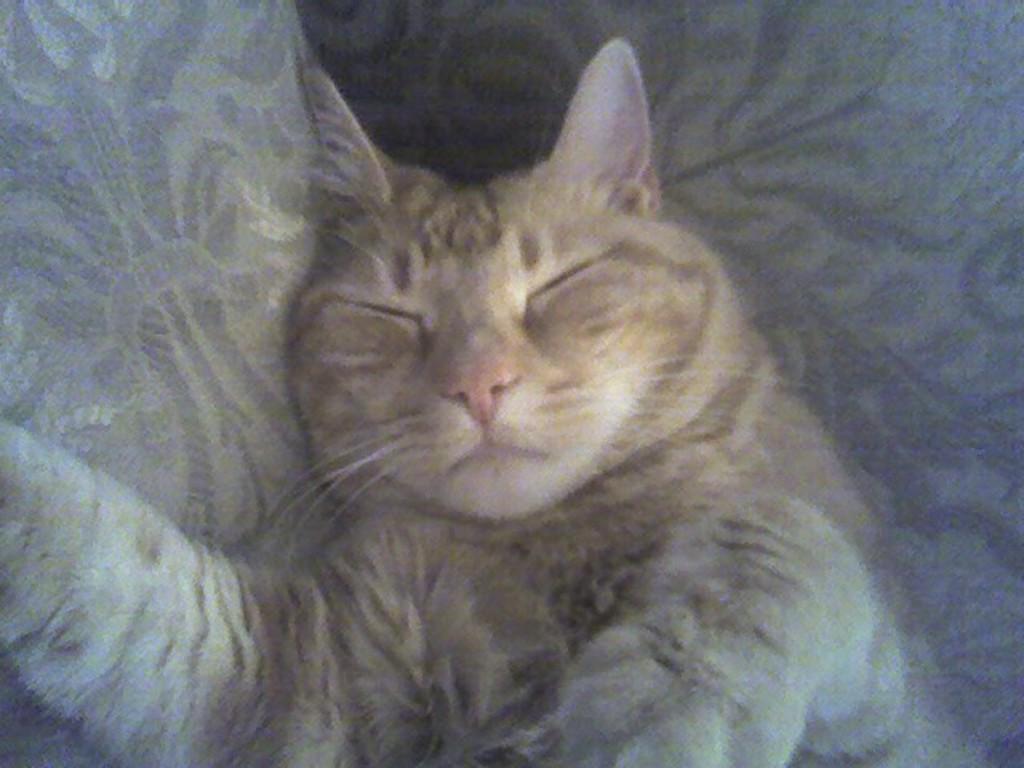Describe this image in one or two sentences. In the center of this picture we can see a cat seems to be sleeping on an object. 